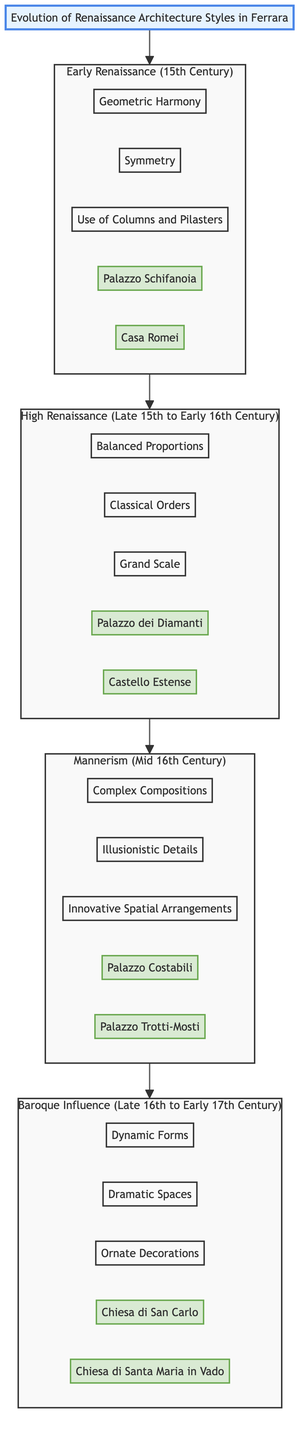What is the time period for Early Renaissance? The diagram indicates that Early Renaissance corresponds to the 15th Century. The data block for Early Renaissance specifies this time period clearly.
Answer: 15th Century Which architecture style has Palazzo dei Diamanti as a representative building? The diagram shows the link from the High Renaissance block to the representative building Palazzo dei Diamanti. This correlation confirms that it belongs to the High Renaissance style.
Answer: High Renaissance How many key features are listed for Mannerism? By counting the key features listed under the Mannerism block in the diagram, we see it contains three specific features: Complex Compositions, Illusionistic Details, and Innovative Spatial Arrangements.
Answer: 3 What is a key feature of Baroque Influence? The diagram indicates three key features for Baroque Influence, one of which is Dynamic Forms. This is clearly stated in the Baroque block of the diagram.
Answer: Dynamic Forms Which architectural style introduced Grand Scale? The diagram's High Renaissance block explicitly lists Grand Scale as one of its key features, identifying it with that specific style.
Answer: High Renaissance What are the representative buildings for Early Renaissance? The Early Renaissance block contains two buildings listed: Palazzo Schifanoia and Casa Romei. The creations under this block are direct indicators of this style.
Answer: Palazzo Schifanoia, Casa Romei What style follows Mannerism in the diagram? The layout of the diagram shows an arrow leading from the Mannerism block to the Baroque Influence block, indicating Baroque Influence directly follows Mannerism.
Answer: Baroque Influence How many architectural styles are represented in the diagram? By counting all the main architectural styles presented (Early Renaissance, High Renaissance, Mannerism, and Baroque Influence), the total gives us four distinct styles.
Answer: 4 